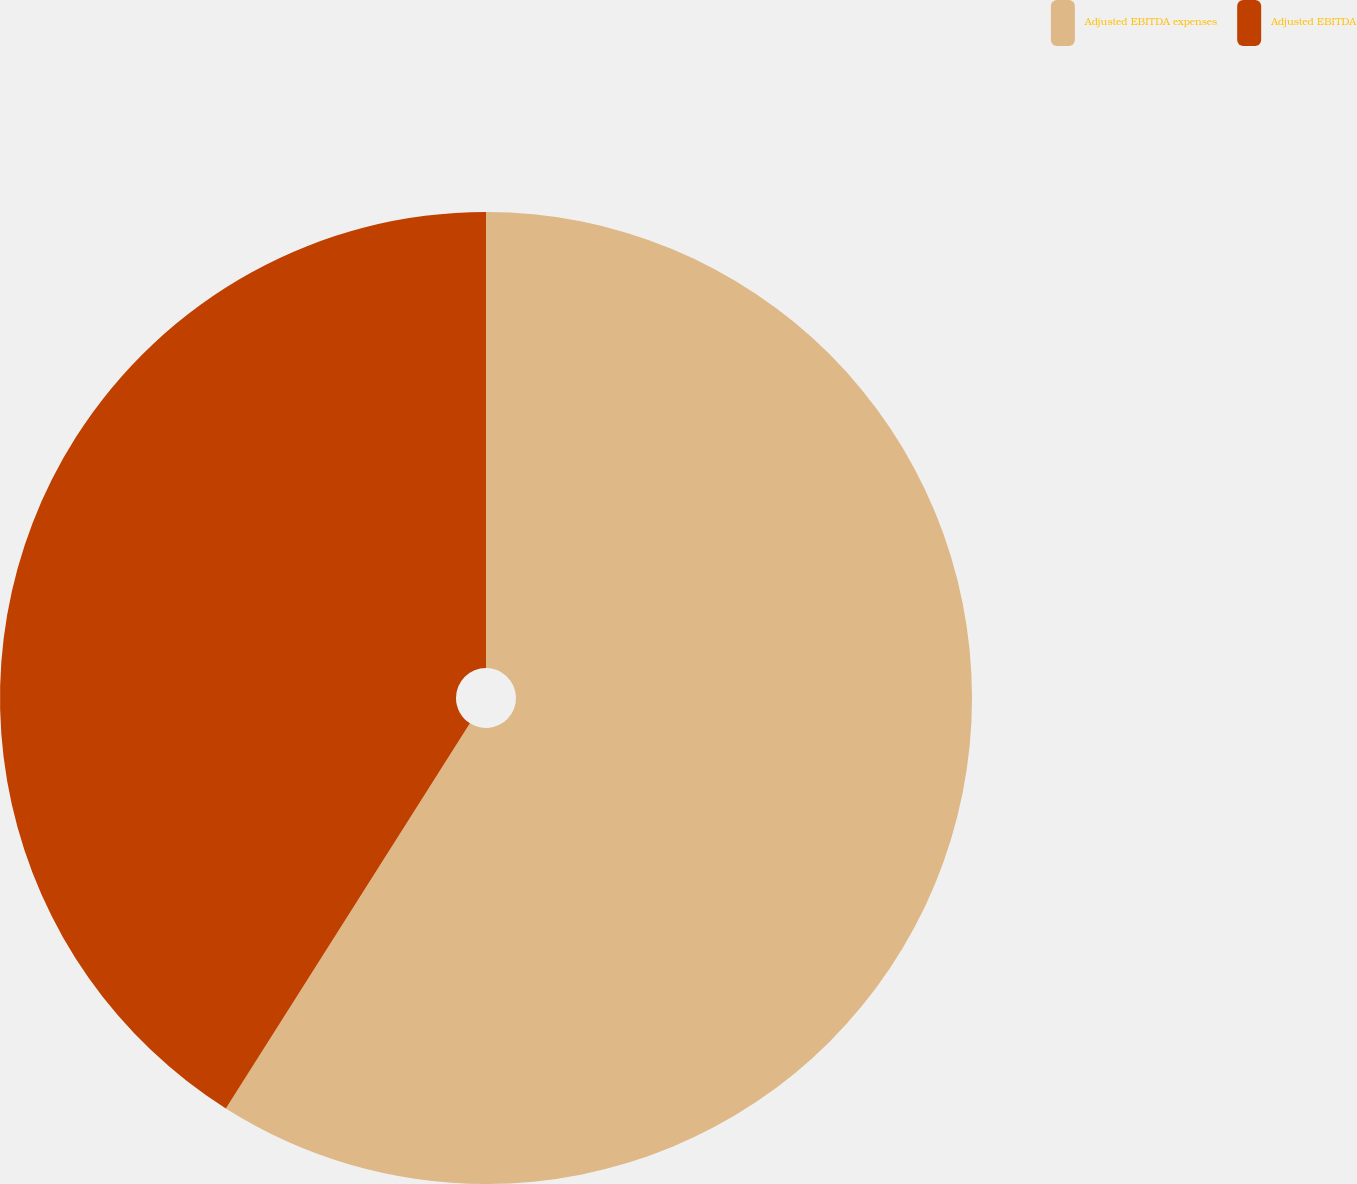<chart> <loc_0><loc_0><loc_500><loc_500><pie_chart><fcel>Adjusted EBITDA expenses<fcel>Adjusted EBITDA<nl><fcel>58.99%<fcel>41.01%<nl></chart> 